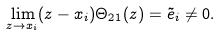<formula> <loc_0><loc_0><loc_500><loc_500>\lim _ { z \to x _ { i } } ( z - x _ { i } ) \Theta _ { 2 1 } ( z ) = \tilde { e } _ { i } \neq 0 .</formula> 